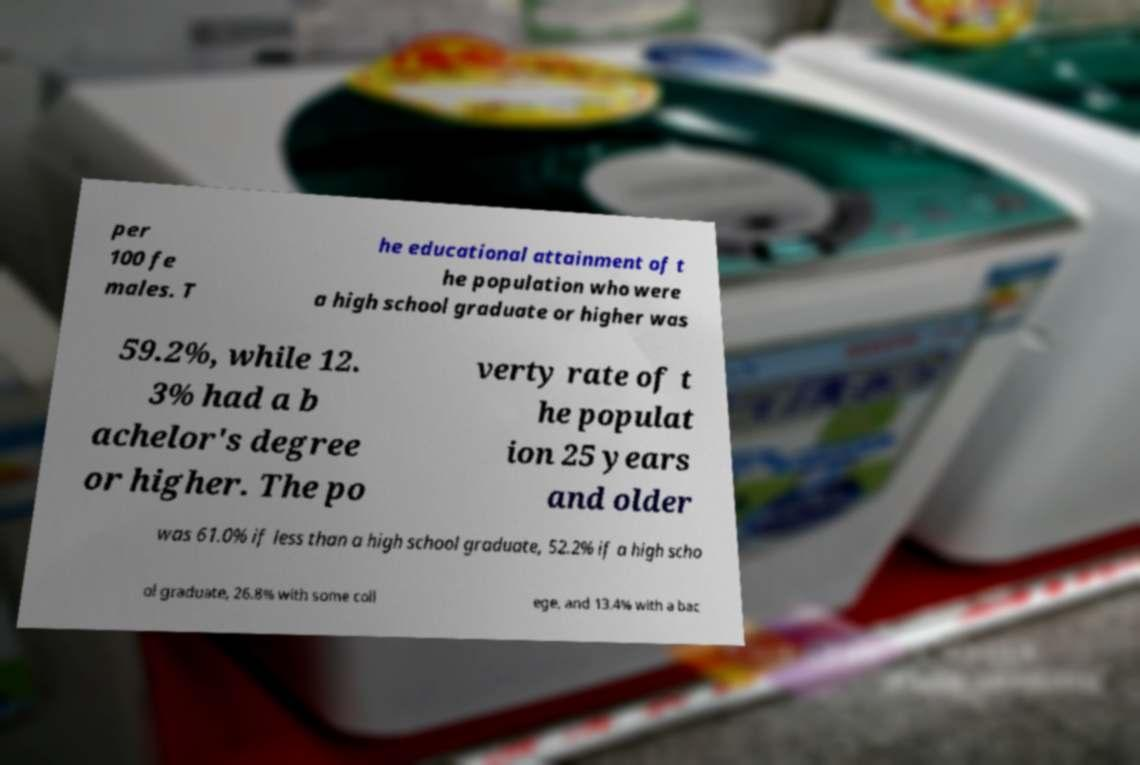Can you read and provide the text displayed in the image?This photo seems to have some interesting text. Can you extract and type it out for me? per 100 fe males. T he educational attainment of t he population who were a high school graduate or higher was 59.2%, while 12. 3% had a b achelor's degree or higher. The po verty rate of t he populat ion 25 years and older was 61.0% if less than a high school graduate, 52.2% if a high scho ol graduate, 26.8% with some coll ege, and 13.4% with a bac 